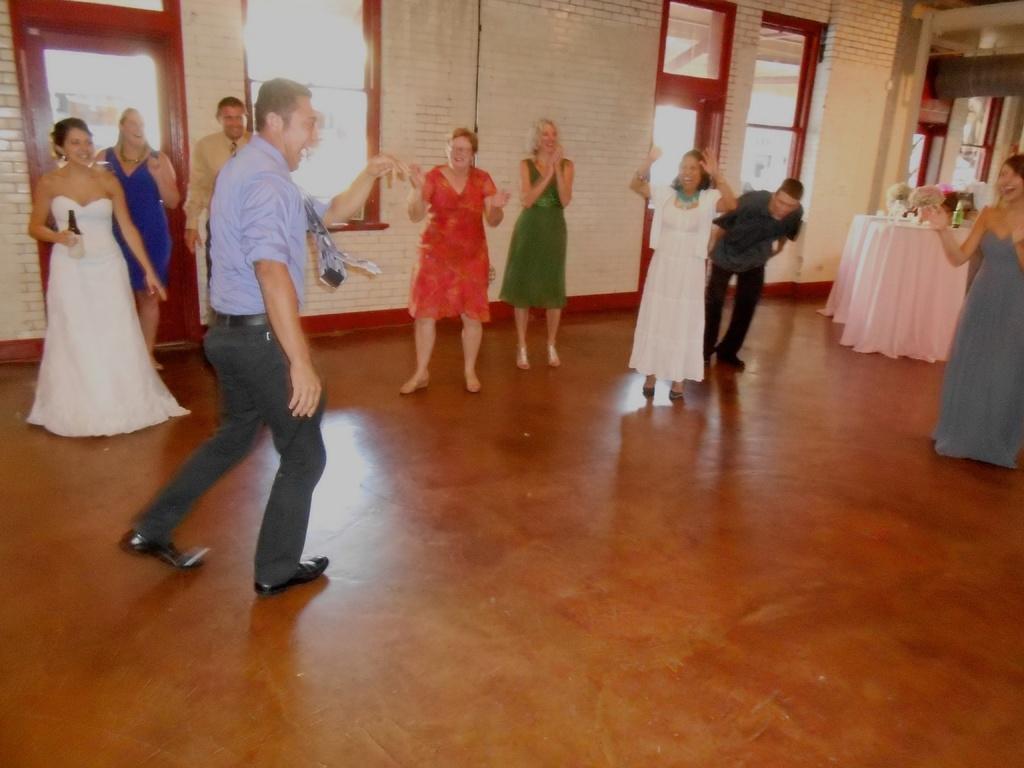Can you describe this image briefly? In this picture we can see a person dancing on the floor. There is a woman holding a bottle in her hand on the left side. We can see a few people standing and clapping. There is a bottle, flowers, white cloth and other objects are visible on a table. We can see a few windows and a door on the left side. 